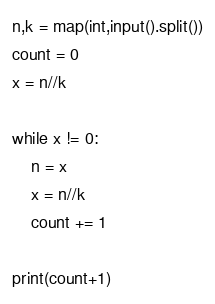Convert code to text. <code><loc_0><loc_0><loc_500><loc_500><_Python_>n,k = map(int,input().split())
count = 0
x = n//k

while x != 0:
    n = x
    x = n//k
    count += 1

print(count+1)</code> 